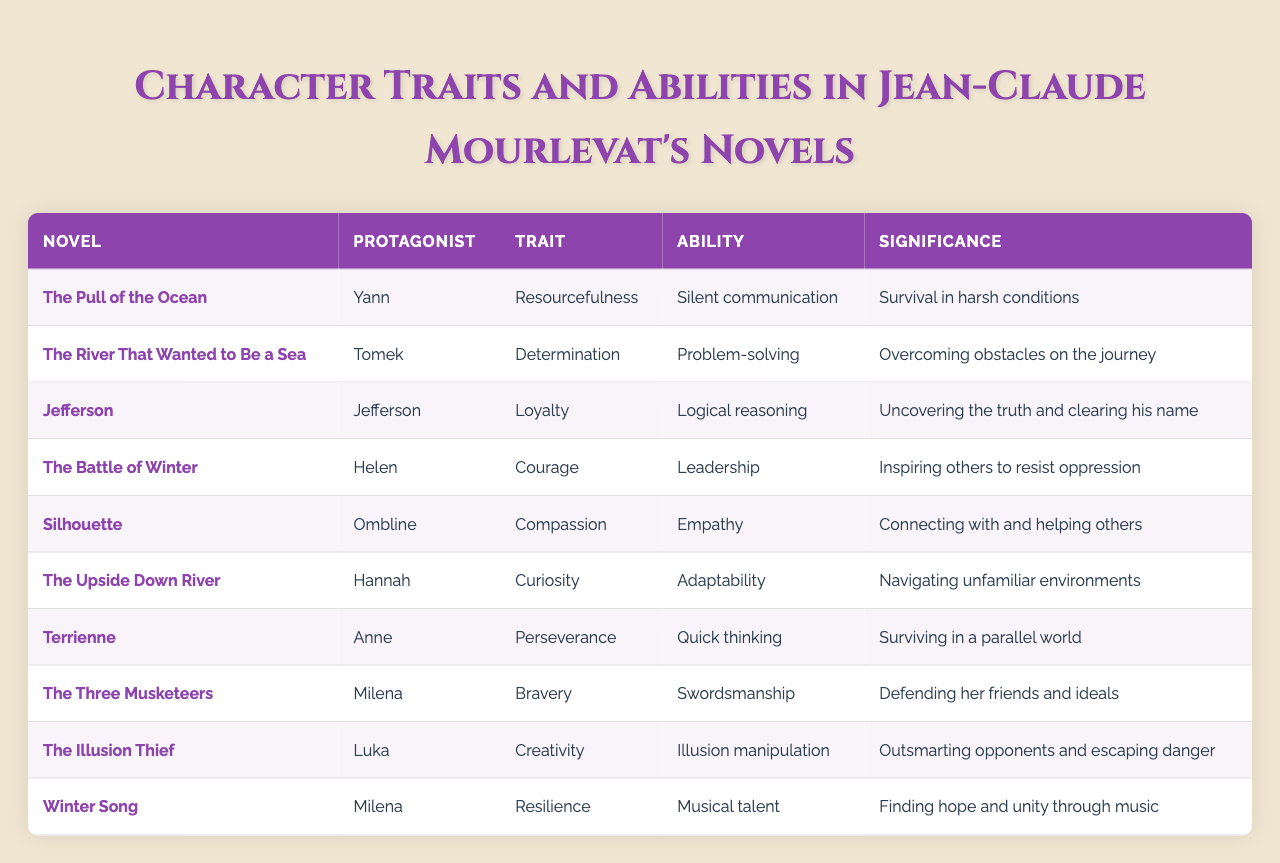What is the trait of the protagonist in "Terrienne"? Looking at the table, in the row corresponding to "Terrienne," the trait listed for the protagonist Anne is "Perseverance."
Answer: Perseverance Which protagonist is known for their ability of swordsmanship? Referring to the table, the protagonist Milena from "The Three Musketeers" is mentioned as having the ability of "Swordsmanship."
Answer: Milena How many protagonists exhibit the trait of "Courage"? The table lists only one protagonist, Helen from "The Battle of Winter," who has the trait of "Courage," so the count is 1.
Answer: 1 Does the protagonist in "The Illusion Thief" show creativity as a trait? According to the table, Luka, the protagonist of "The Illusion Thief," indeed has "Creativity" listed as his trait, making the statement true.
Answer: Yes Which protagonist from "Winter Song" is associated with resilience, and what is their ability? From the table, Milena from "Winter Song" is associated with the trait of "Resilience" and her ability is "Musical talent."
Answer: Milena, Musical talent What are the abilities of the protagonists who demonstrate the trait "Determination"? Only one protagonist, Tomek from "The River That Wanted to Be a Sea," demonstrates "Determination," and his ability is "Problem-solving."
Answer: Problem-solving Which ability is linked to the trait of empathy? The table shows that Ombline from "Silhouette" has the ability of "Empathy" linked to her trait of "Compassion."
Answer: Empathy What is the sum of the number of protagonists who have both leadership and bravery as traits? According to the table, there is 1 protagonist with "Leadership" (Helen) and another with "Bravery" (Milena), so the sum is 1 + 1 = 2.
Answer: 2 Which protagonist in "The Pull of the Ocean" has skills in silent communication? The information in the table indicates that Yann from "The Pull of the Ocean" has the ability of "Silent communication."
Answer: Yann Is there a protagonist who exhibits both loyalty and logical reasoning? The table identifies Jefferson from "Jefferson" who demonstrates the trait of "Loyalty" along with the ability of "Logical reasoning," confirming the statement as true.
Answer: Yes 